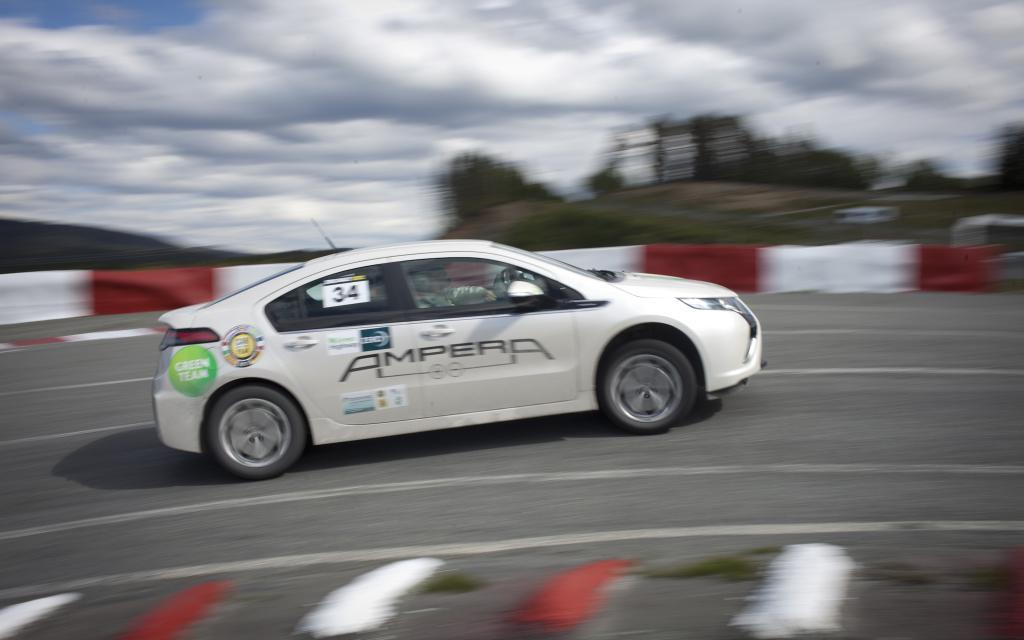What is the main subject of the image? The main subject of the image is a car. Where is the car located in the image? The car is on the road in the image. What can be seen in the sky in the image? There are clouds in the sky in the image. How many trees can be seen in the image? There are no trees visible in the image. 